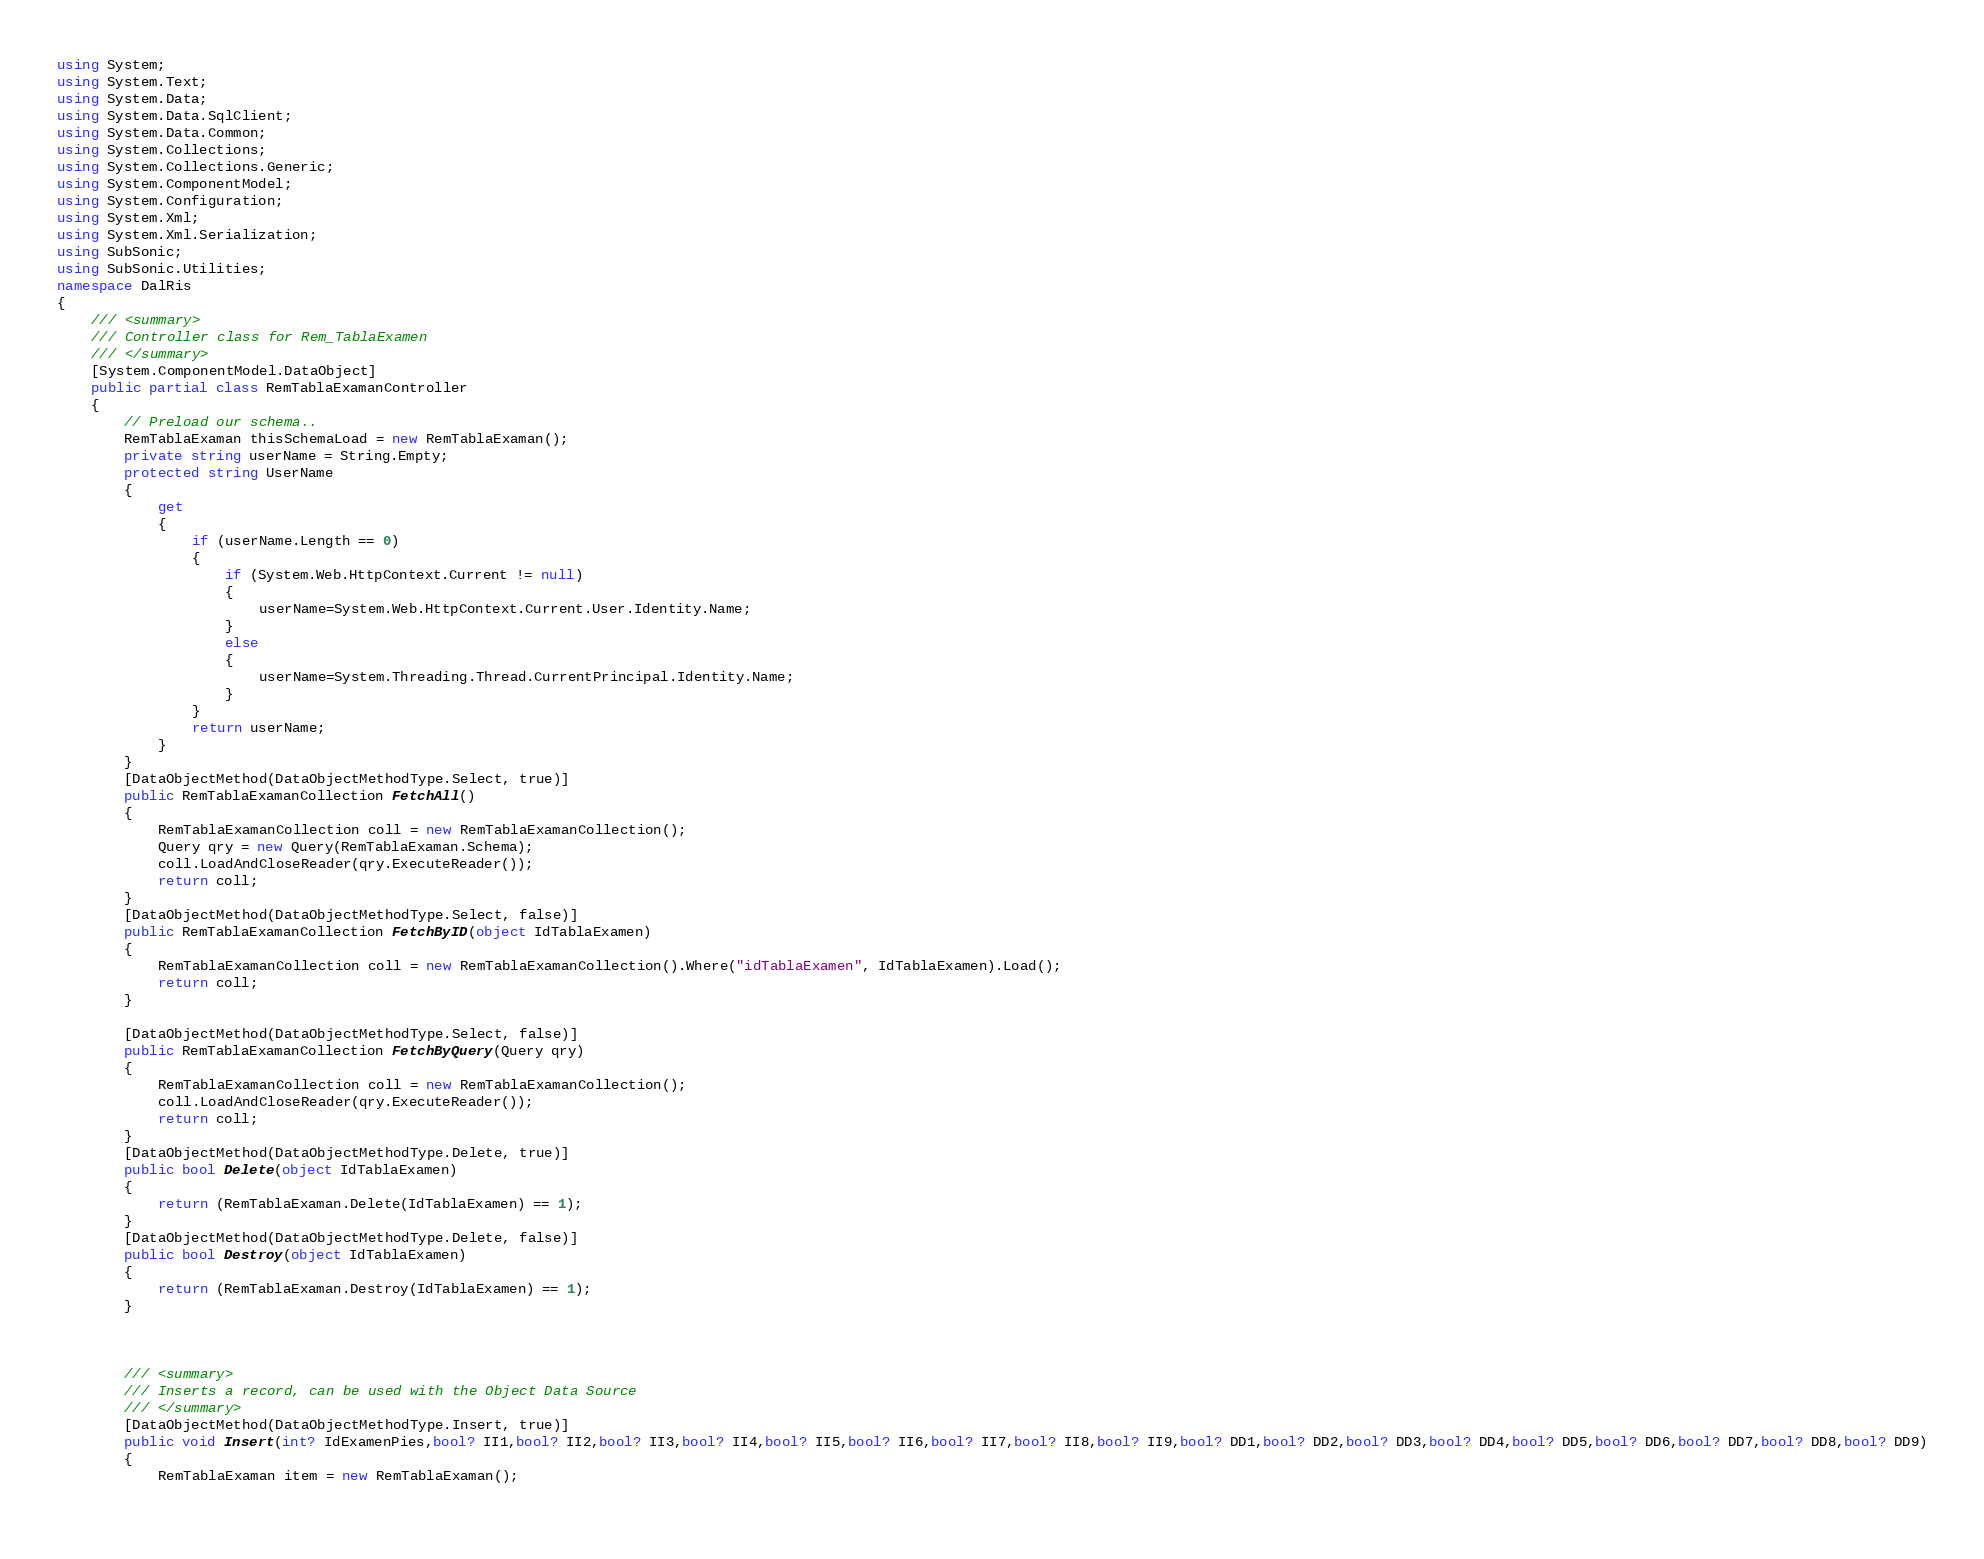Convert code to text. <code><loc_0><loc_0><loc_500><loc_500><_C#_>using System; 
using System.Text; 
using System.Data;
using System.Data.SqlClient;
using System.Data.Common;
using System.Collections;
using System.Collections.Generic;
using System.ComponentModel;
using System.Configuration; 
using System.Xml; 
using System.Xml.Serialization;
using SubSonic; 
using SubSonic.Utilities;
namespace DalRis
{
    /// <summary>
    /// Controller class for Rem_TablaExamen
    /// </summary>
    [System.ComponentModel.DataObject]
    public partial class RemTablaExamanController
    {
        // Preload our schema..
        RemTablaExaman thisSchemaLoad = new RemTablaExaman();
        private string userName = String.Empty;
        protected string UserName
        {
            get
            {
				if (userName.Length == 0) 
				{
    				if (System.Web.HttpContext.Current != null)
    				{
						userName=System.Web.HttpContext.Current.User.Identity.Name;
					}
					else
					{
						userName=System.Threading.Thread.CurrentPrincipal.Identity.Name;
					}
				}
				return userName;
            }
        }
        [DataObjectMethod(DataObjectMethodType.Select, true)]
        public RemTablaExamanCollection FetchAll()
        {
            RemTablaExamanCollection coll = new RemTablaExamanCollection();
            Query qry = new Query(RemTablaExaman.Schema);
            coll.LoadAndCloseReader(qry.ExecuteReader());
            return coll;
        }
        [DataObjectMethod(DataObjectMethodType.Select, false)]
        public RemTablaExamanCollection FetchByID(object IdTablaExamen)
        {
            RemTablaExamanCollection coll = new RemTablaExamanCollection().Where("idTablaExamen", IdTablaExamen).Load();
            return coll;
        }
		
		[DataObjectMethod(DataObjectMethodType.Select, false)]
        public RemTablaExamanCollection FetchByQuery(Query qry)
        {
            RemTablaExamanCollection coll = new RemTablaExamanCollection();
            coll.LoadAndCloseReader(qry.ExecuteReader()); 
            return coll;
        }
        [DataObjectMethod(DataObjectMethodType.Delete, true)]
        public bool Delete(object IdTablaExamen)
        {
            return (RemTablaExaman.Delete(IdTablaExamen) == 1);
        }
        [DataObjectMethod(DataObjectMethodType.Delete, false)]
        public bool Destroy(object IdTablaExamen)
        {
            return (RemTablaExaman.Destroy(IdTablaExamen) == 1);
        }
        
        
    	
	    /// <summary>
	    /// Inserts a record, can be used with the Object Data Source
	    /// </summary>
        [DataObjectMethod(DataObjectMethodType.Insert, true)]
	    public void Insert(int? IdExamenPies,bool? II1,bool? II2,bool? II3,bool? II4,bool? II5,bool? II6,bool? II7,bool? II8,bool? II9,bool? DD1,bool? DD2,bool? DD3,bool? DD4,bool? DD5,bool? DD6,bool? DD7,bool? DD8,bool? DD9)
	    {
		    RemTablaExaman item = new RemTablaExaman();
		    </code> 